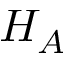<formula> <loc_0><loc_0><loc_500><loc_500>H _ { A }</formula> 